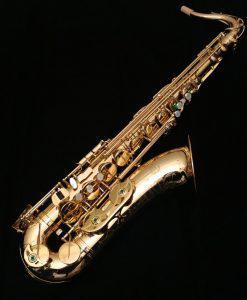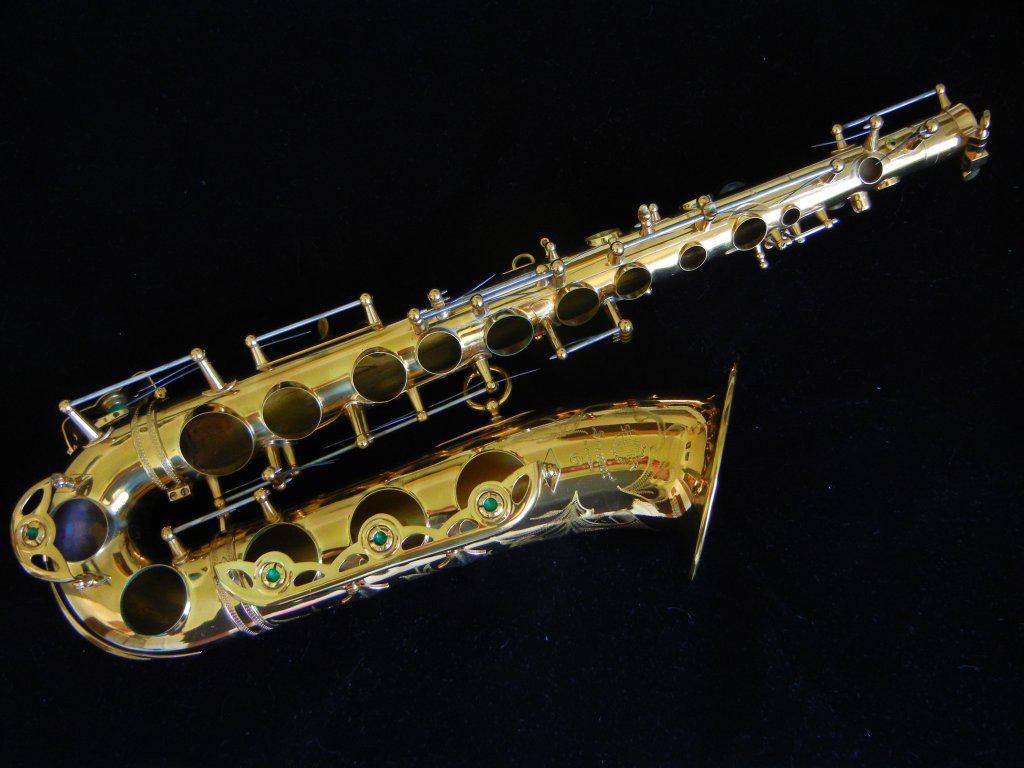The first image is the image on the left, the second image is the image on the right. For the images shown, is this caption "In at least one image there is a full saxophone laying down with the open hole in front." true? Answer yes or no. No. The first image is the image on the left, the second image is the image on the right. For the images shown, is this caption "One image shows a saxophone with a curved bell end that has its mouthpiece separate and lying near the saxophone's bell." true? Answer yes or no. No. 